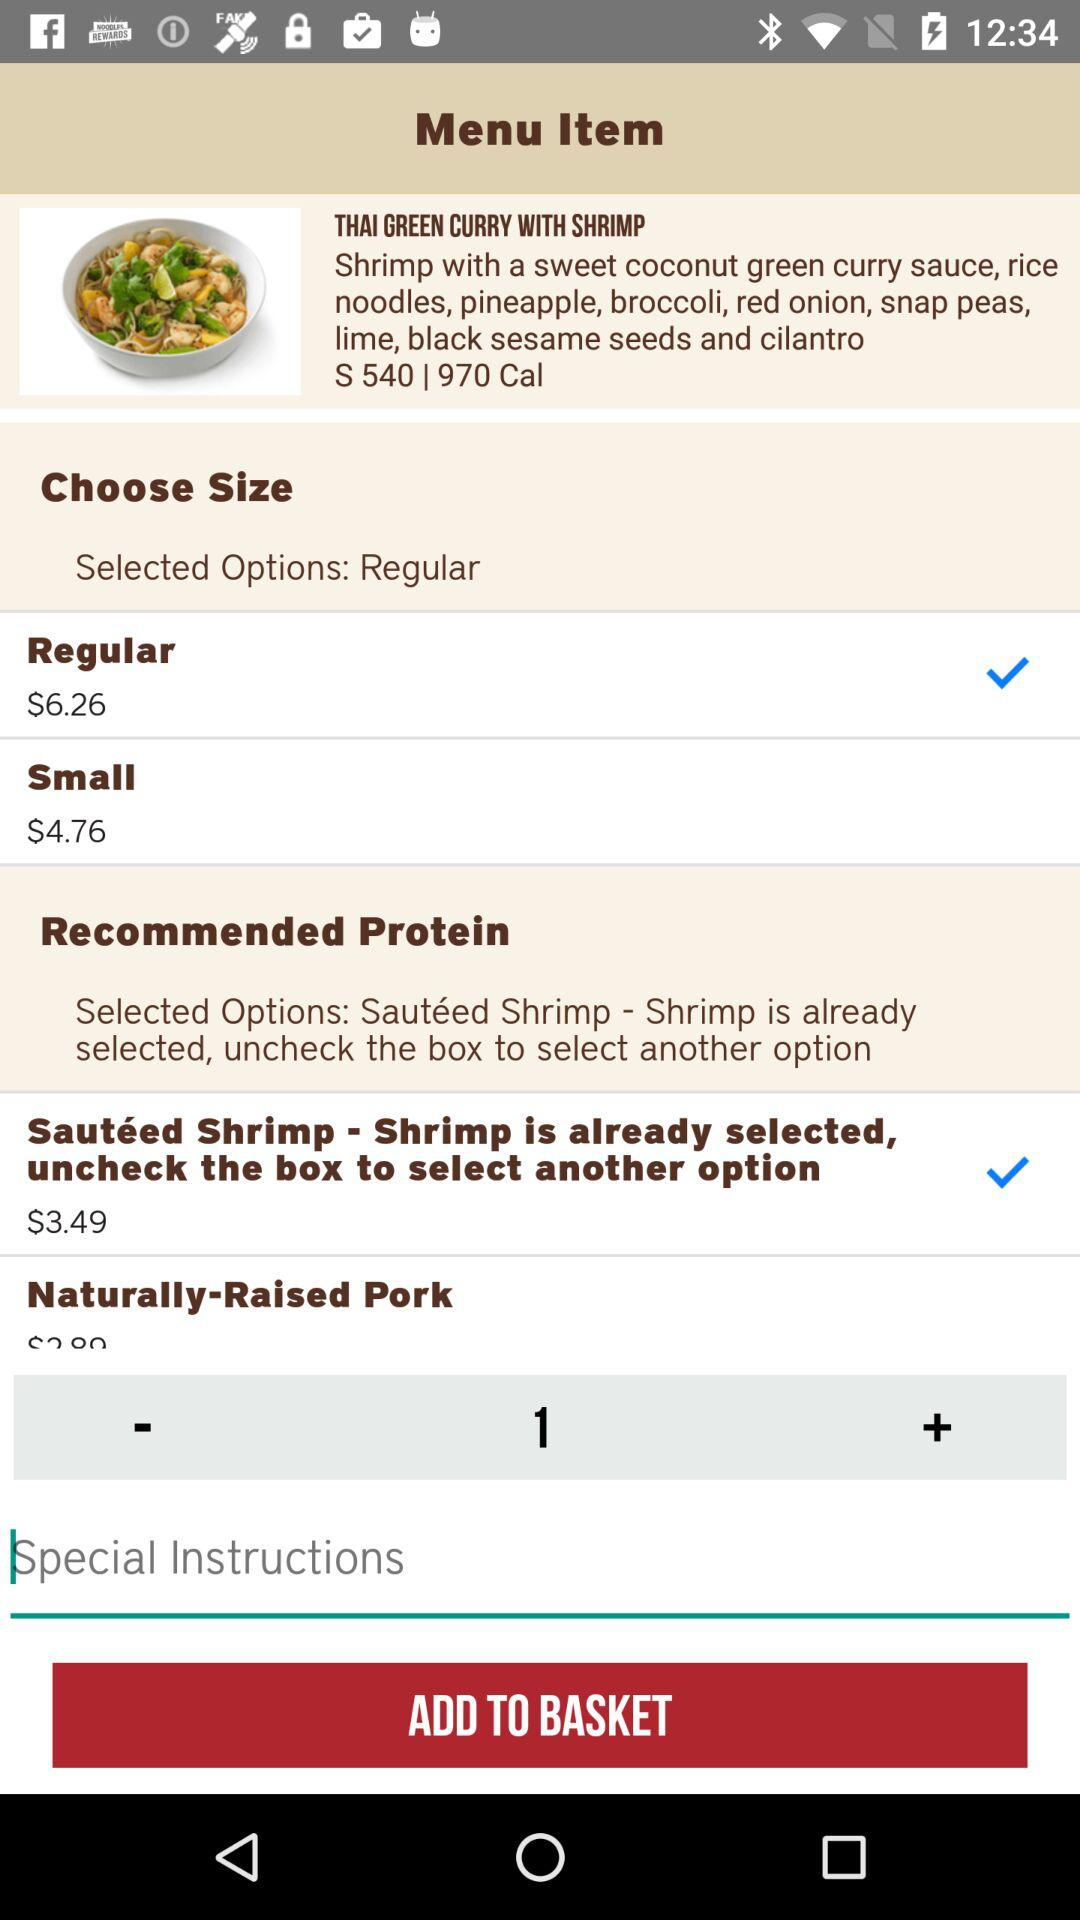What is the price of the small size? The price of the small size is $4.76. 